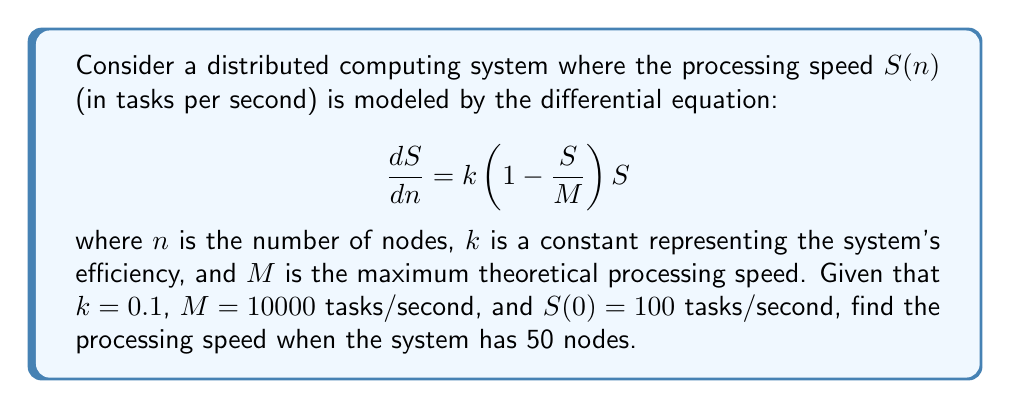Teach me how to tackle this problem. To solve this problem, we need to follow these steps:

1) First, recognize that this is a logistic differential equation, which models growth with a limiting factor.

2) The general solution to this equation is:

   $$S(n) = \frac{M}{1 + Ce^{-kMn}}$$

   where $C$ is a constant we need to determine from the initial condition.

3) Using the initial condition $S(0) = 100$, we can find $C$:

   $$100 = \frac{10000}{1 + C}$$
   $$C = 99$$

4) Now we have the complete solution:

   $$S(n) = \frac{10000}{1 + 99e^{-1000n}}$$

5) To find the processing speed at 50 nodes, we simply plug in $n = 50$:

   $$S(50) = \frac{10000}{1 + 99e^{-1000(50)}}$$

6) Calculating this (you may use a calculator):

   $$S(50) \approx 9999.999999999996$$

7) Rounding to a reasonable number of significant figures:

   $$S(50) \approx 10000$$ tasks/second

This result shows that with 50 nodes, the system has essentially reached its maximum theoretical processing speed.
Answer: $S(50) \approx 10000$ tasks/second 